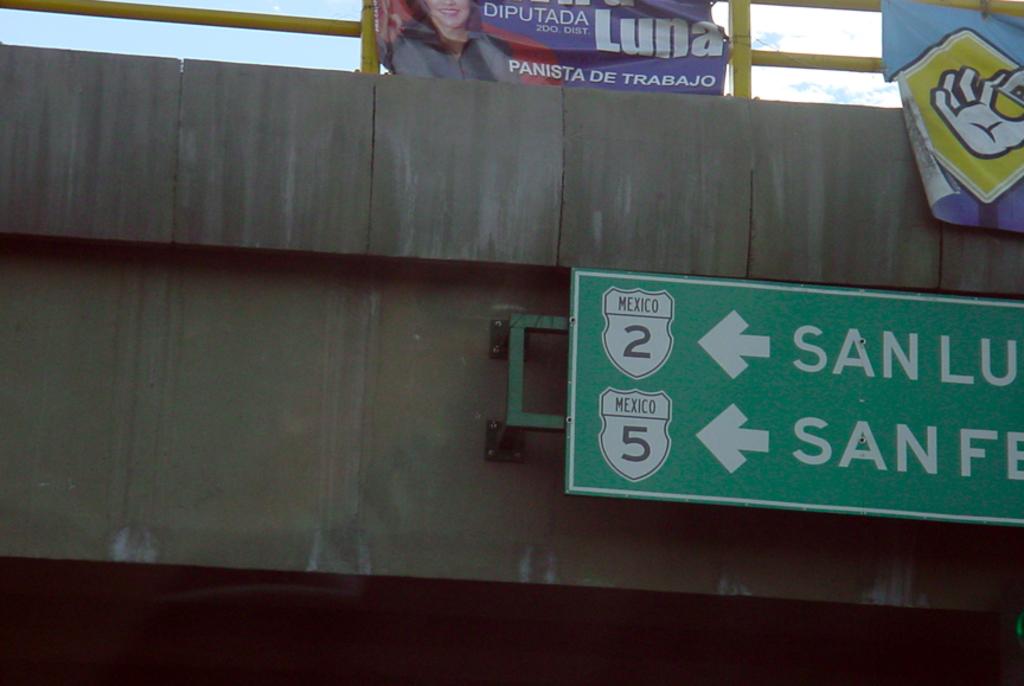What numbers are under the words mexico on the sign?
Ensure brevity in your answer.  2 and 5. 